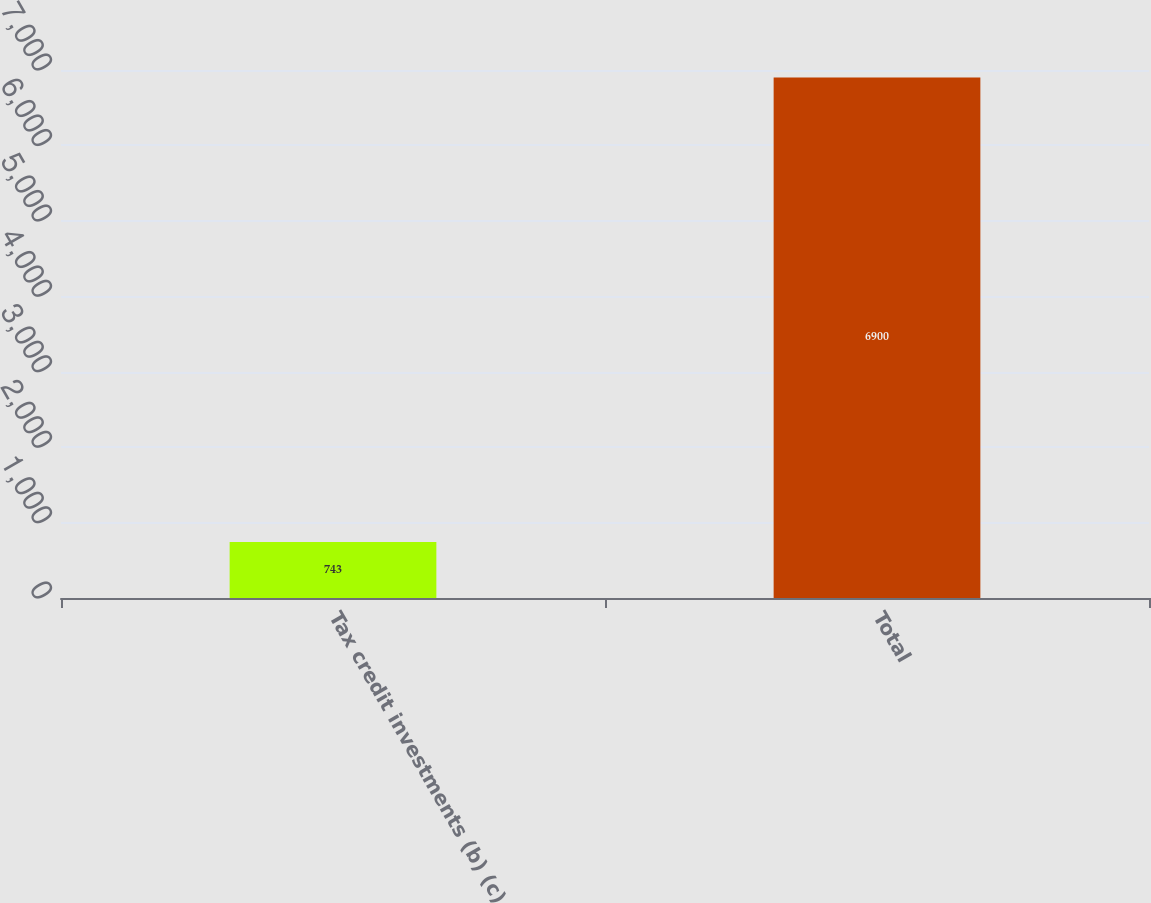Convert chart. <chart><loc_0><loc_0><loc_500><loc_500><bar_chart><fcel>Tax credit investments (b) (c)<fcel>Total<nl><fcel>743<fcel>6900<nl></chart> 